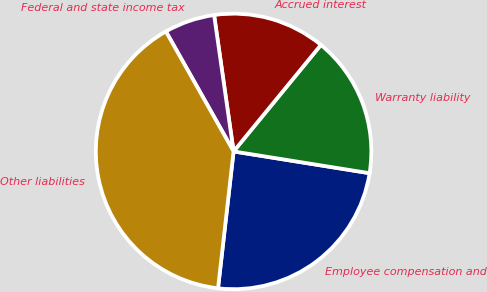<chart> <loc_0><loc_0><loc_500><loc_500><pie_chart><fcel>Employee compensation and<fcel>Warranty liability<fcel>Accrued interest<fcel>Federal and state income tax<fcel>Other liabilities<nl><fcel>24.28%<fcel>16.6%<fcel>13.19%<fcel>5.92%<fcel>40.03%<nl></chart> 